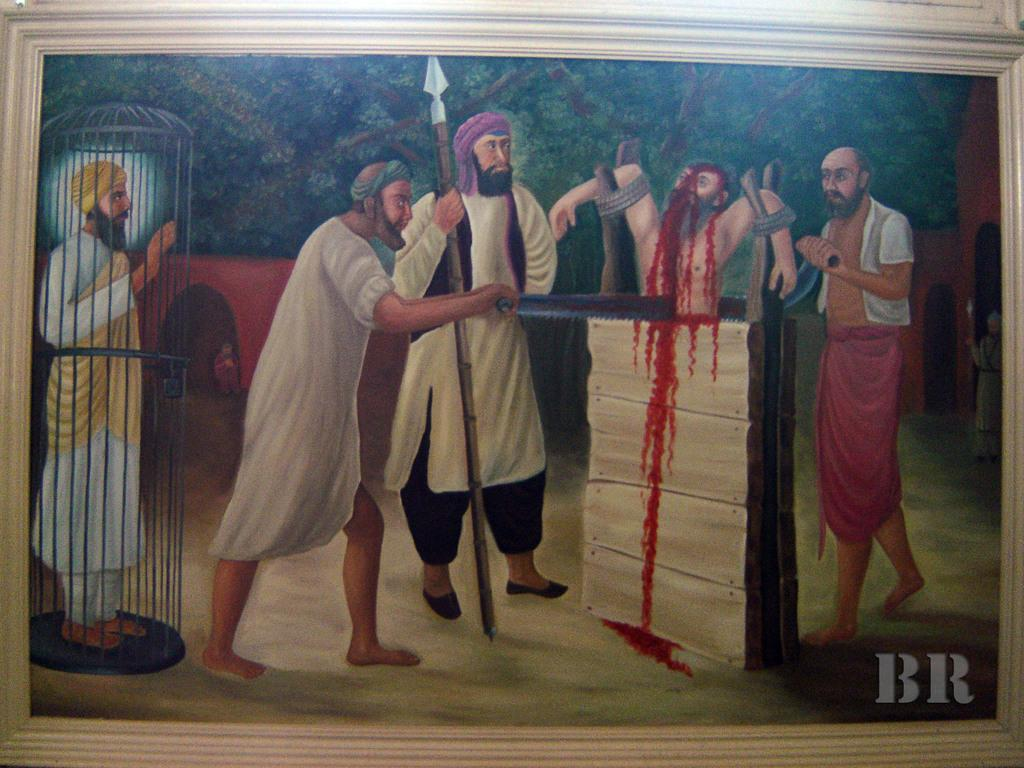What is the main subject of the painting in the image? Unfortunately, we cannot determine the main subject of the painting from the given facts. What can be seen around the painting in the image? There are people visible in the image. What type of cherries are being picked on the trail in the image? There is no mention of cherries or a trail in the given facts, so we cannot answer this question. 